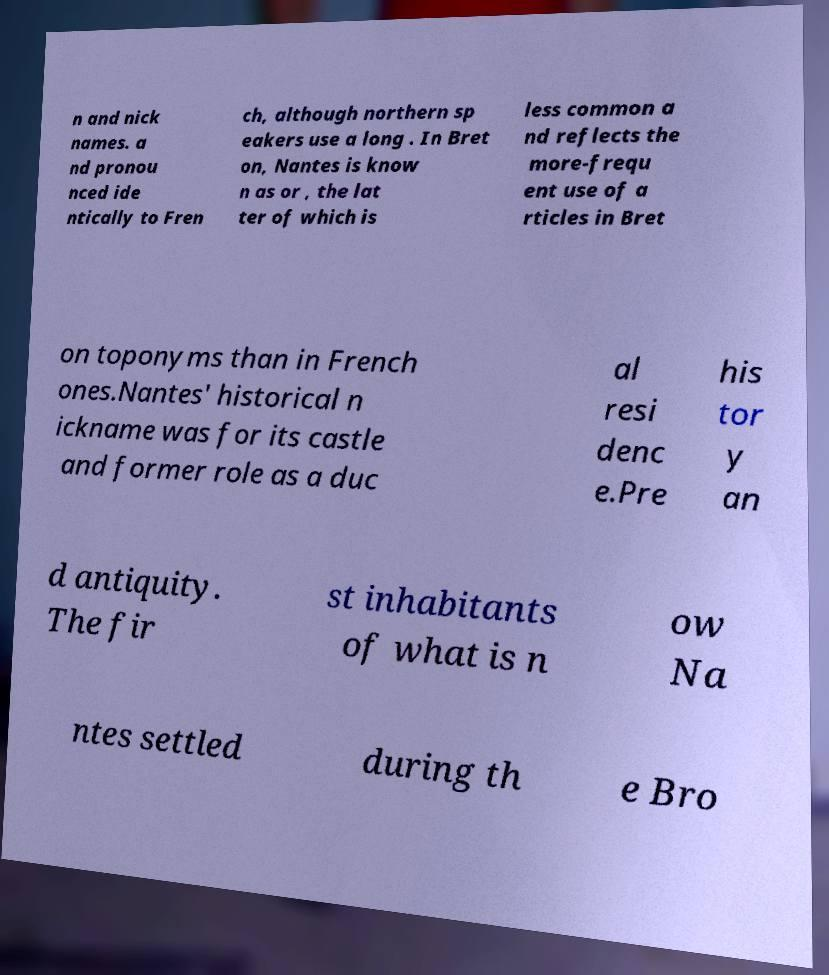I need the written content from this picture converted into text. Can you do that? n and nick names. a nd pronou nced ide ntically to Fren ch, although northern sp eakers use a long . In Bret on, Nantes is know n as or , the lat ter of which is less common a nd reflects the more-frequ ent use of a rticles in Bret on toponyms than in French ones.Nantes' historical n ickname was for its castle and former role as a duc al resi denc e.Pre his tor y an d antiquity. The fir st inhabitants of what is n ow Na ntes settled during th e Bro 